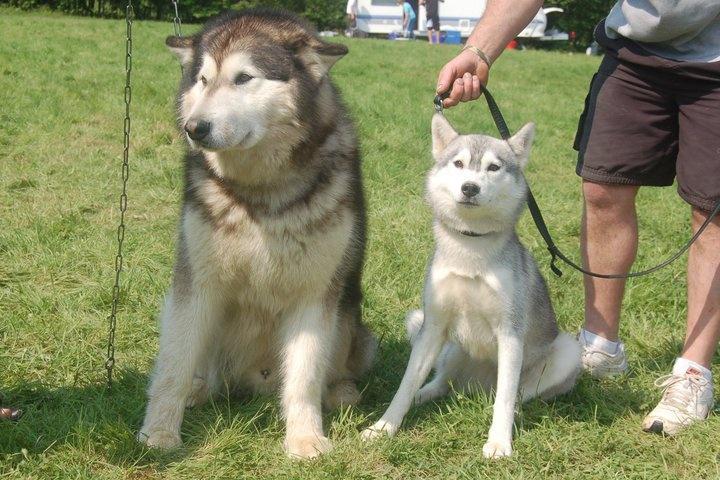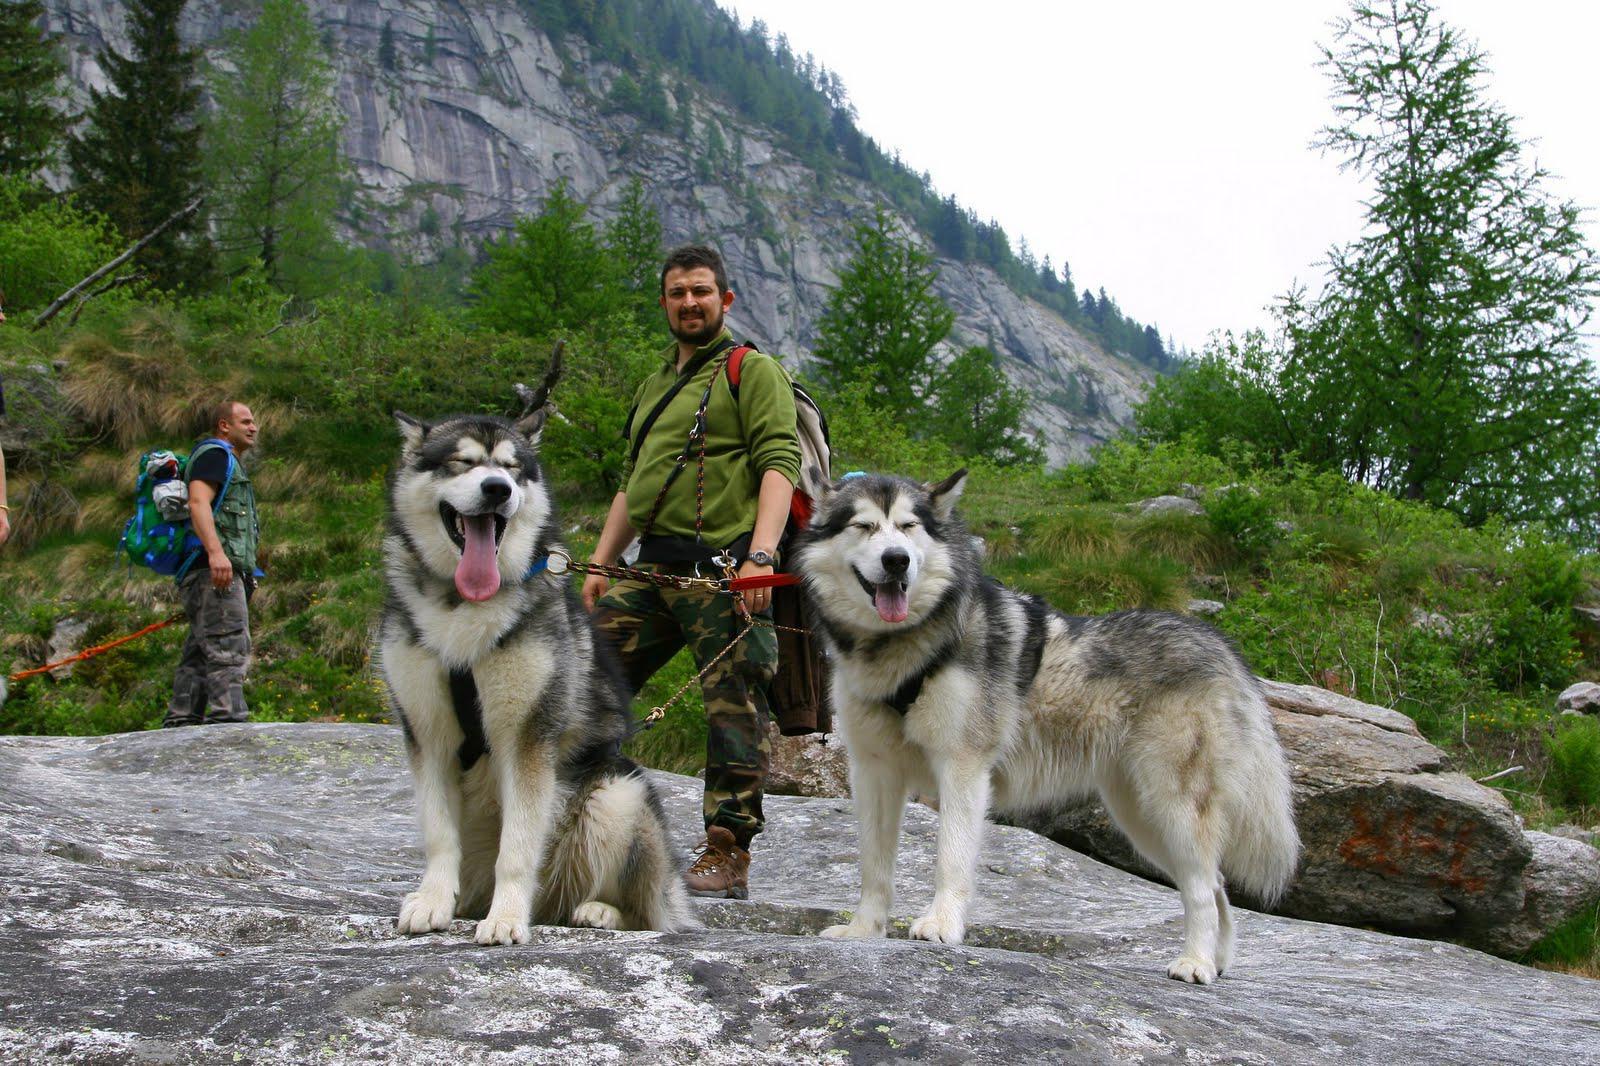The first image is the image on the left, the second image is the image on the right. Examine the images to the left and right. Is the description "A dog is standing next to a person." accurate? Answer yes or no. Yes. 